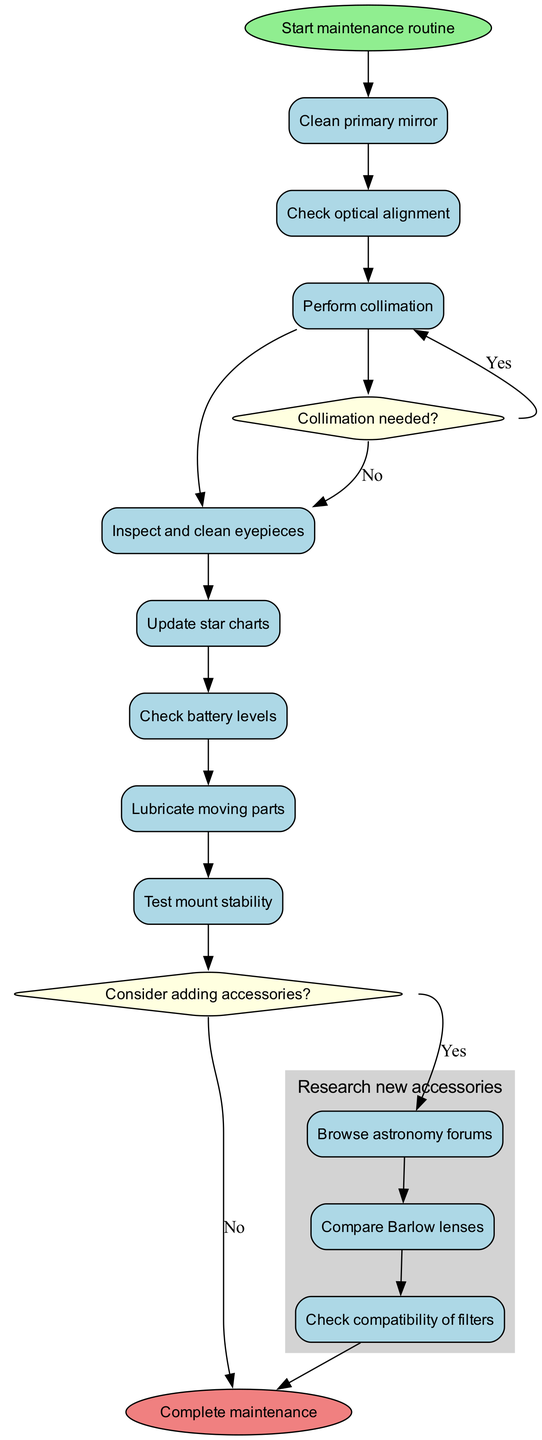What is the first activity in the maintenance routine? The diagram starts with the initial node labeled "Start maintenance routine," which then leads to the first activity. According to the sequence, the first activity is "Clean primary mirror."
Answer: Clean primary mirror How many activities are listed in the diagram? There are a total of 8 activities listed in the diagram, including cleaning, checking, and testing. This includes both the main activities and the subprocess activities related to accessories.
Answer: 8 What decision follows the "Perform collimation" activity? After "Perform collimation," the flow leads to a decision node that asks, "Collimation needed?" This decision determines the next step based on whether collimation is needed or not.
Answer: Collimation needed? What happens if "Yes" is chosen in the "Consider adding accessories?" decision? If "Yes" is selected in the "Consider adding accessories?" decision, the flow directs to the subprocess named "Research new accessories," where activities like "Browse astronomy forums," "Compare Barlow lenses," and "Check compatibility of filters" are executed.
Answer: Research new accessories How many total subprocess activities are involved in researching new accessories? Within the subprocess "Research new accessories," there are 3 specific activities listed: "Browse astronomy forums," "Compare Barlow lenses," and "Check compatibility of filters." This totals up to 3 subprocess activities.
Answer: 3 What is the final node in this activity diagram? The final node in the activity diagram is labeled "Complete maintenance," indicating the end of the maintenance routine after all activities and decisions have been performed.
Answer: Complete maintenance What is the first decision that follows the "Perform collimation" activity? The first decision after the "Perform collimation" activity is whether "Collimation needed?" This decision influences the next steps depending on the answer to the question.
Answer: Collimation needed? If "No" is chosen for the "Collimation needed?" decision, which activity follows next? If "No" is selected for the "Collimation needed?" decision, the flow leads to the next activity labeled "Inspect and clean eyepieces," which is where the maintenance task continues.
Answer: Inspect and clean eyepieces 